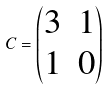Convert formula to latex. <formula><loc_0><loc_0><loc_500><loc_500>C = \begin{pmatrix} 3 & 1 \\ 1 & 0 \end{pmatrix}</formula> 